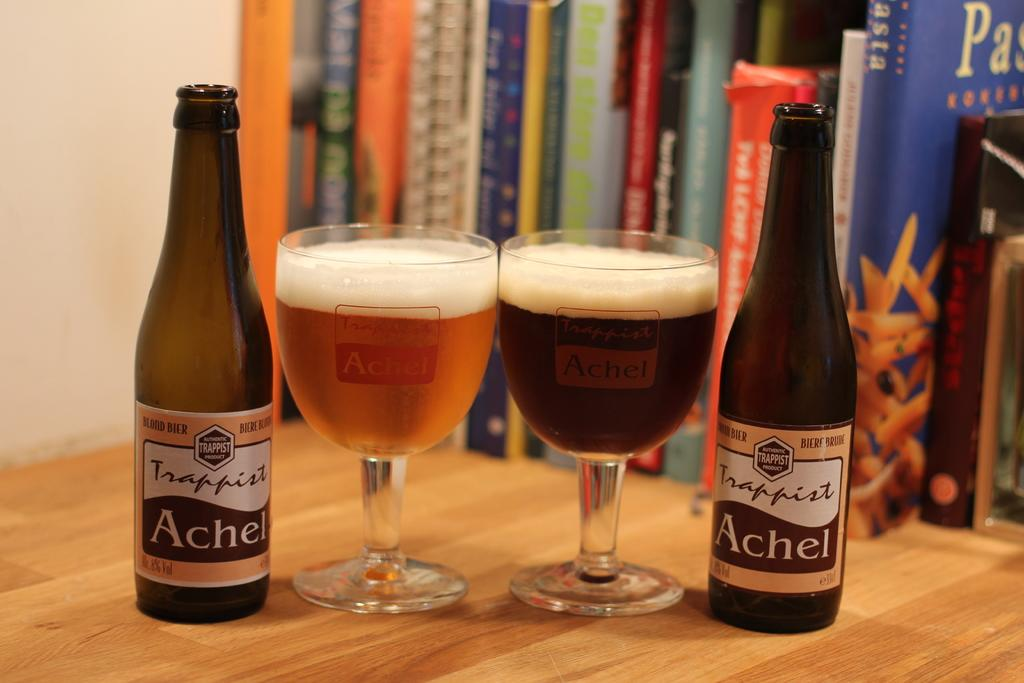What type of surface is visible in the image? There is a wooden surface in the image. What items are placed on the wooden surface? There are books, glasses with liquids, and bottles on the wooden surface. What can be seen in the background of the image? There is a wall visible in the image. How does the wooden surface help the person sail in the image? There is no person sailing in the image, nor is there any reference to sailing. The wooden surface is simply a surface for holding items. 